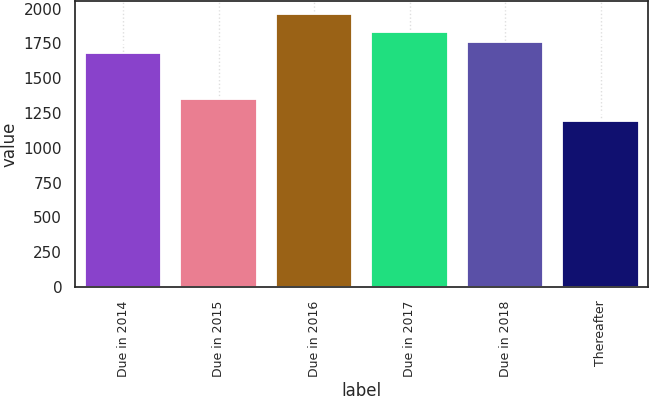<chart> <loc_0><loc_0><loc_500><loc_500><bar_chart><fcel>Due in 2014<fcel>Due in 2015<fcel>Due in 2016<fcel>Due in 2017<fcel>Due in 2018<fcel>Thereafter<nl><fcel>1680<fcel>1351<fcel>1959<fcel>1833.4<fcel>1756.7<fcel>1192<nl></chart> 